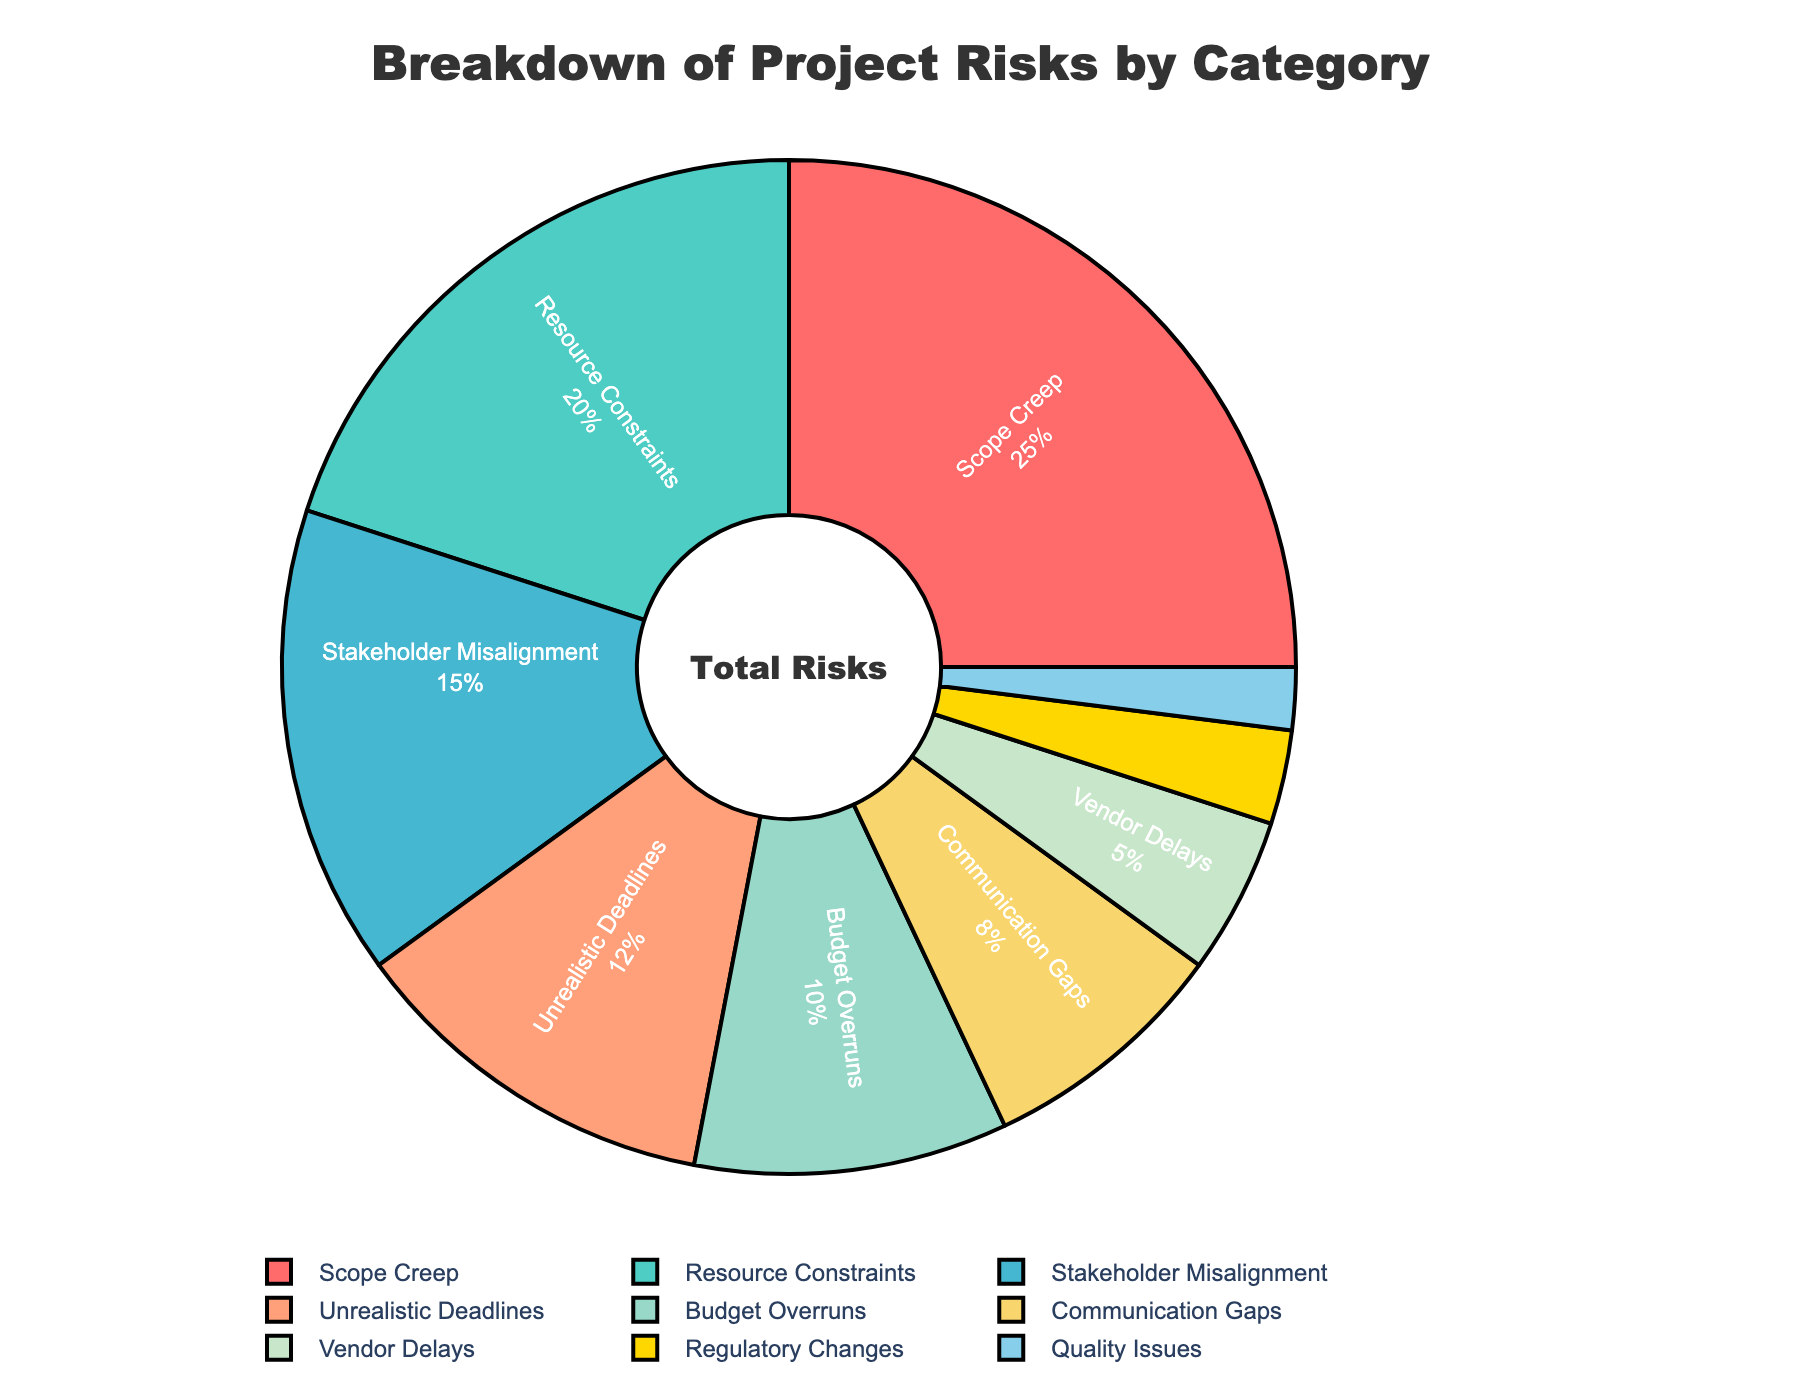What percentage of total risks is attributed to Scope Creep and Resource Constraints combined? To find this, sum the percentages for Scope Creep (25%) and Resource Constraints (20%). 25% + 20% = 45%.
Answer: 45% Which risk category has the smallest percentage? Identify the category with the smallest percentage in the dataset, which is Quality Issues at 2%.
Answer: Quality Issues Is the percentage of risks due to Unrealistic Deadlines greater than those due to Budget Overruns? Compare the percentages: Unrealistic Deadlines (12%) and Budget Overruns (10%). Since 12% > 10%, the answer is yes.
Answer: Yes Which risk category has a higher percentage: Communication Gaps or Vendor Delays? Compare the percentages: Communication Gaps (8%) and Vendor Delays (5%). Since 8% > 5%, Communication Gaps have a higher percentage.
Answer: Communication Gaps What is the percentage difference between Regulatory Changes and Quality Issues? Calculate the difference between the percentages of Regulatory Changes (3%) and Quality Issues (2%). 3% - 2% = 1%.
Answer: 1% How many categories have a percentage of 10% or higher? Count the categories with percentages of 10% or higher: Scope Creep (25%), Resource Constraints (20%), Stakeholder Misalignment (15%), Unrealistic Deadlines (12%), and Budget Overruns (10%). There are 5 such categories.
Answer: 5 Which risk category is represented by the red-colored section in the pie chart? Identify the category associated with the red-colored section, which is Scope Creep.
Answer: Scope Creep Are Communication Gaps and Vendor Delays together responsible for more or less than 15% of total risks? Sum the percentages for Communication Gaps (8%) and Vendor Delays (5%). 8% + 5% = 13%. Since 13% < 15%, they are responsible for less.
Answer: Less Does the sum of percentages for Stakeholder Misalignment and Budget Overruns equal the percentage for Scope Creep? Sum the percentages for Stakeholder Misalignment (15%) and Budget Overruns (10%). 15% + 10% = 25%, which is equal to the percentage for Scope Creep (25%).
Answer: Yes 